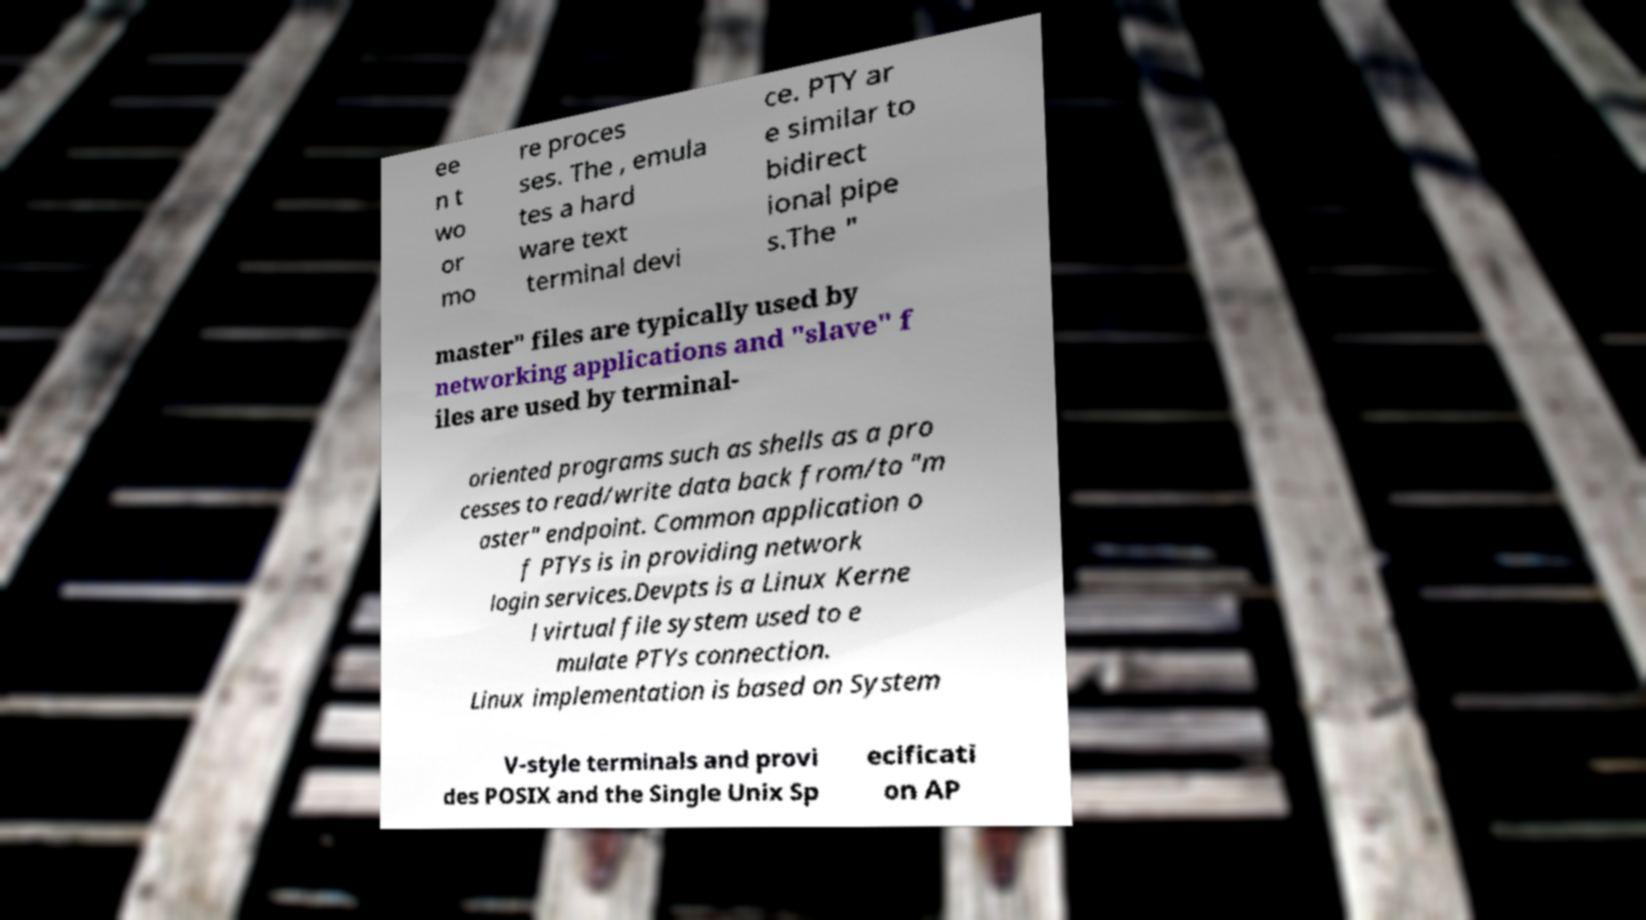Could you assist in decoding the text presented in this image and type it out clearly? ee n t wo or mo re proces ses. The , emula tes a hard ware text terminal devi ce. PTY ar e similar to bidirect ional pipe s.The " master" files are typically used by networking applications and "slave" f iles are used by terminal- oriented programs such as shells as a pro cesses to read/write data back from/to "m aster" endpoint. Common application o f PTYs is in providing network login services.Devpts is a Linux Kerne l virtual file system used to e mulate PTYs connection. Linux implementation is based on System V-style terminals and provi des POSIX and the Single Unix Sp ecificati on AP 